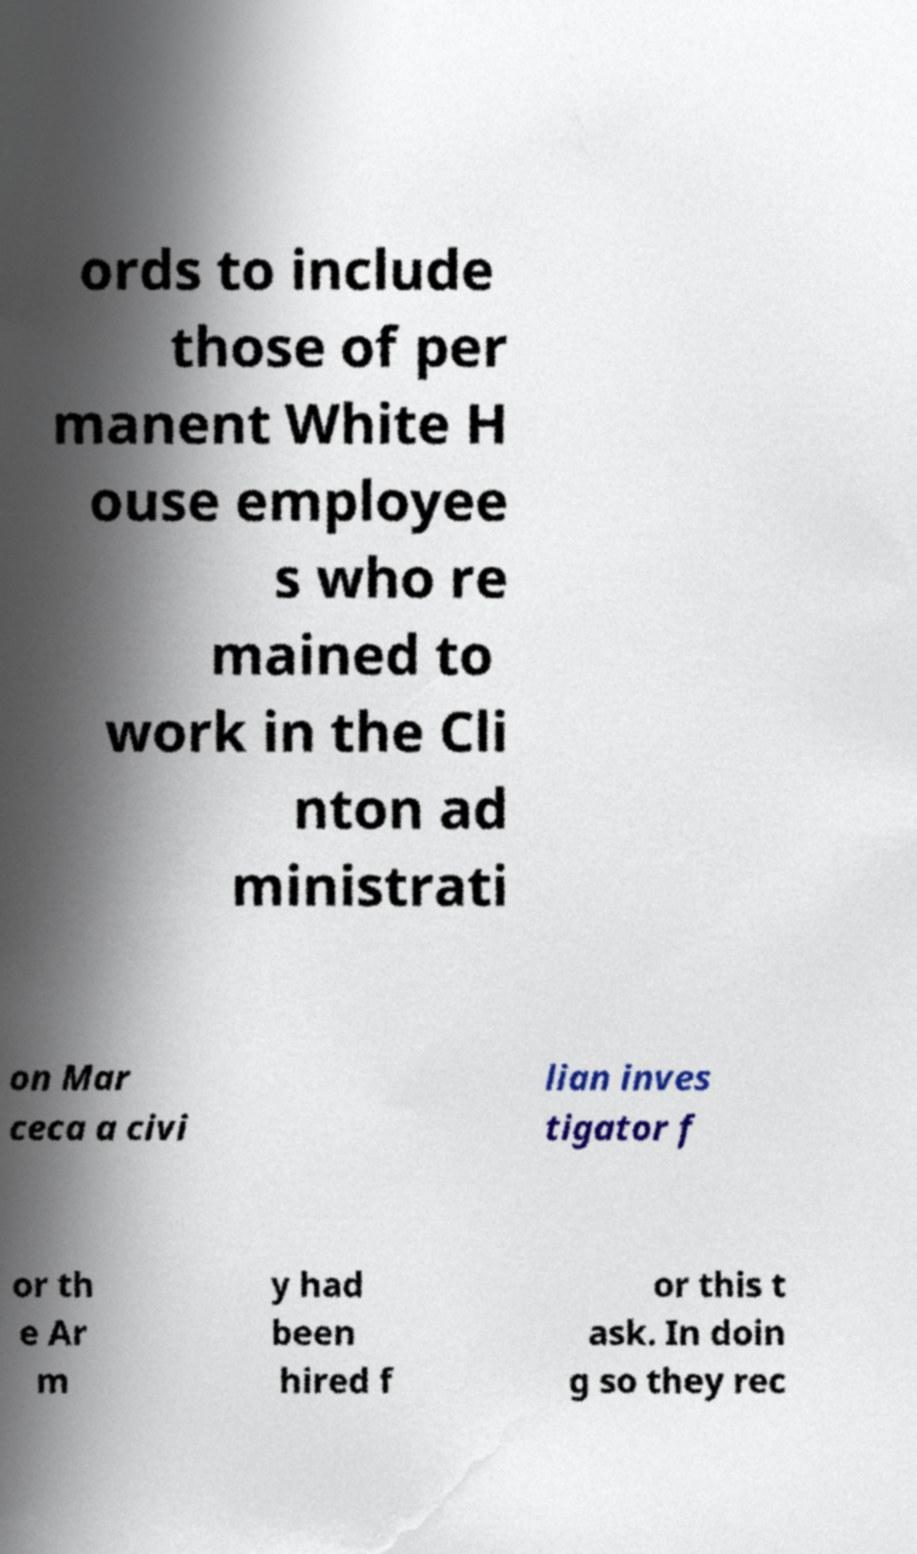Please identify and transcribe the text found in this image. ords to include those of per manent White H ouse employee s who re mained to work in the Cli nton ad ministrati on Mar ceca a civi lian inves tigator f or th e Ar m y had been hired f or this t ask. In doin g so they rec 